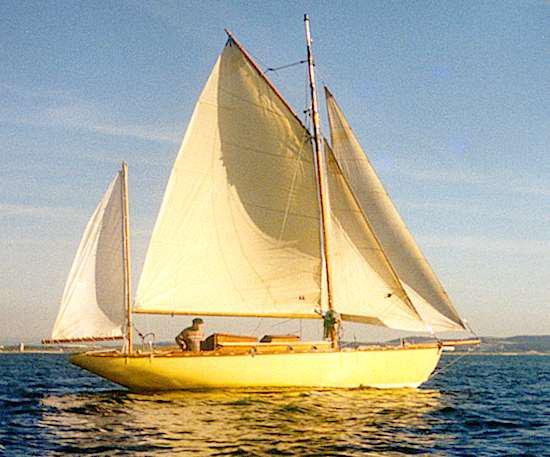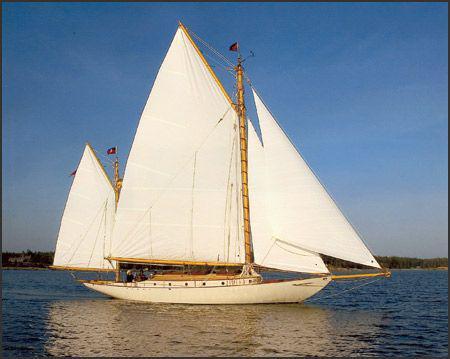The first image is the image on the left, the second image is the image on the right. For the images shown, is this caption "White sea spray surrounds the boat in one of the images." true? Answer yes or no. No. 